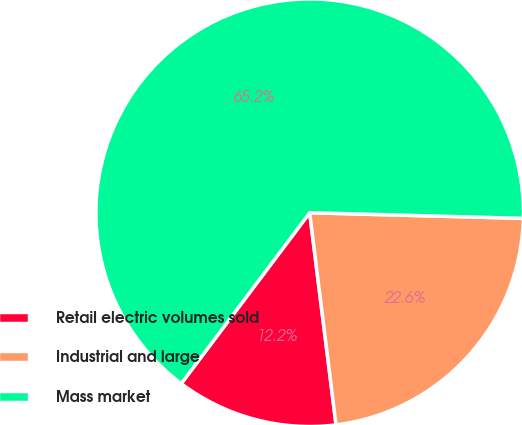Convert chart to OTSL. <chart><loc_0><loc_0><loc_500><loc_500><pie_chart><fcel>Retail electric volumes sold<fcel>Industrial and large<fcel>Mass market<nl><fcel>12.23%<fcel>22.61%<fcel>65.16%<nl></chart> 